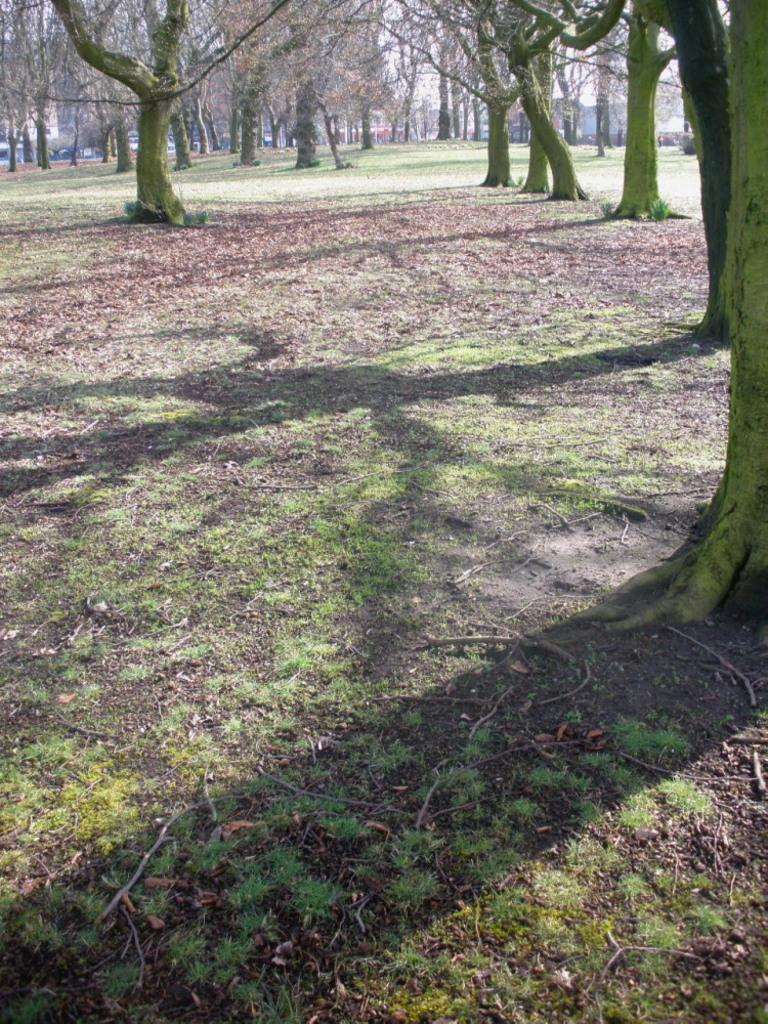What is visible on the ground in the image? The ground is visible in the image, and there is grass on the ground. What type of vegetation can be seen in the image? There are trees in the image. What is visible in the background of the image? The sky is visible in the background of the image, and there are other objects present as well. Can you see a library in the background of the image? There is no library present in the image; it features grass, trees, and other objects in the background. What type of patch can be seen on the grass in the image? There is no patch visible on the grass in the image; it is a continuous expanse of grass. 